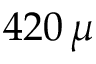<formula> <loc_0><loc_0><loc_500><loc_500>4 2 0 \, \mu</formula> 